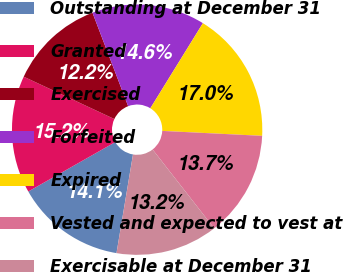<chart> <loc_0><loc_0><loc_500><loc_500><pie_chart><fcel>Outstanding at December 31<fcel>Granted<fcel>Exercised<fcel>Forfeited<fcel>Expired<fcel>Vested and expected to vest at<fcel>Exercisable at December 31<nl><fcel>14.14%<fcel>15.18%<fcel>12.24%<fcel>14.61%<fcel>16.98%<fcel>13.66%<fcel>13.19%<nl></chart> 